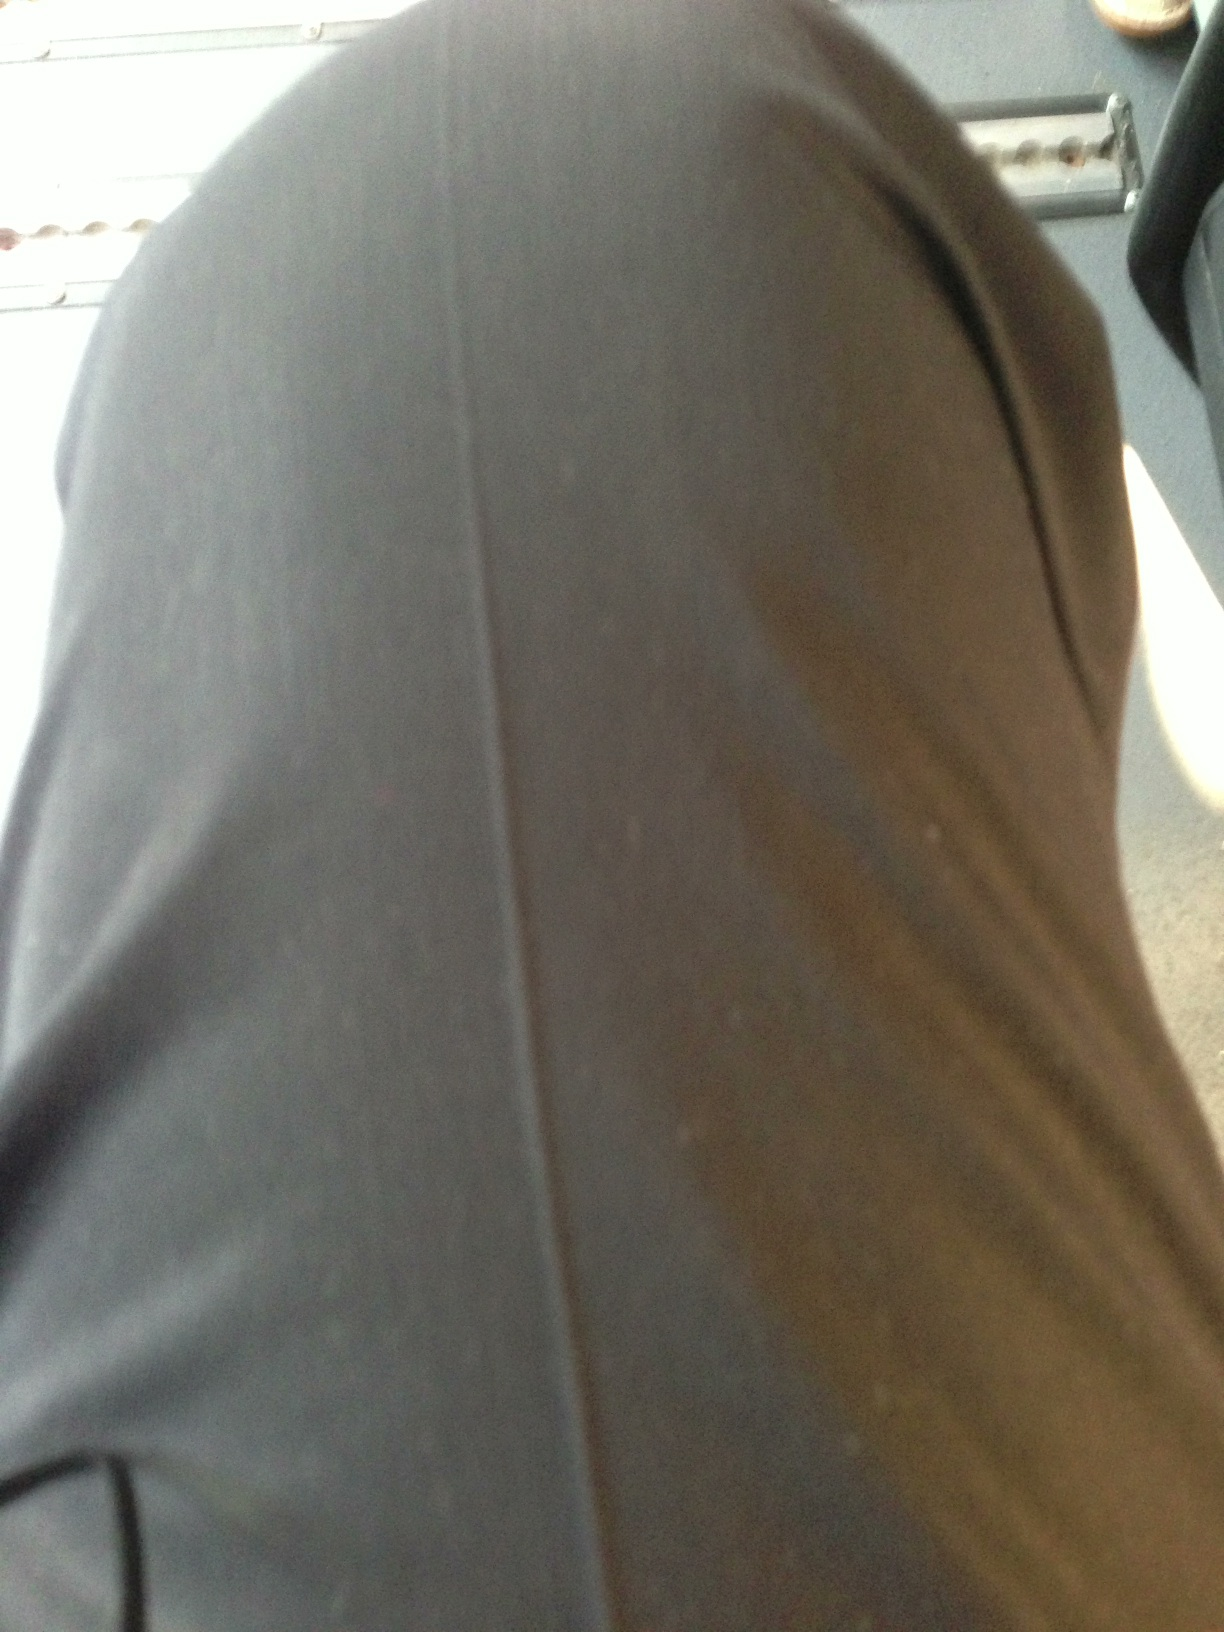What material do these pants appear to be made from? The pants in the image look to be made from a synthetic blend, possibly polyester or a similar material, which gives them a slight sheen and smooth texture. 